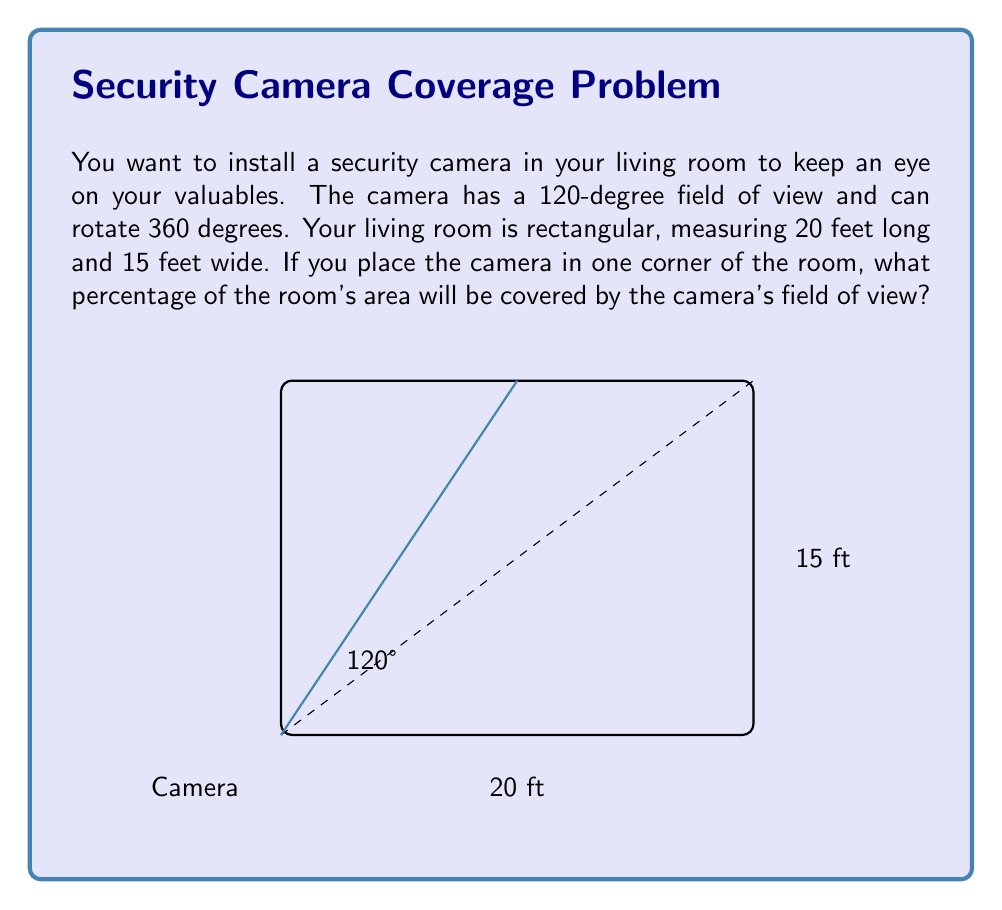Solve this math problem. Let's approach this step-by-step:

1) The camera's field of view forms a sector of a circle. In a rectangular room, this sector will form a triangle.

2) To find the area of this triangle, we need to calculate its base and height.

3) The angle of the sector is 120°. In a right triangle, this angle would be 60° (half of 120°).

4) In a 60-30-90 triangle, the ratio of sides is 1 : √3 : 2.

5) If we consider the shorter wall (15 ft) as the height of our triangle, the base would be:
   $15 * \frac{2}{\sqrt{3}} \approx 17.32$ ft

6) The area of the triangle (camera's coverage) is:
   $A_{triangle} = \frac{1}{2} * 15 * 17.32 = 129.9$ sq ft

7) The total area of the room is:
   $A_{room} = 20 * 15 = 300$ sq ft

8) The percentage of the room covered is:
   $\frac{A_{triangle}}{A_{room}} * 100\% = \frac{129.9}{300} * 100\% \approx 43.3\%$

Therefore, the camera will cover approximately 43.3% of the room's area.
Answer: 43.3% 